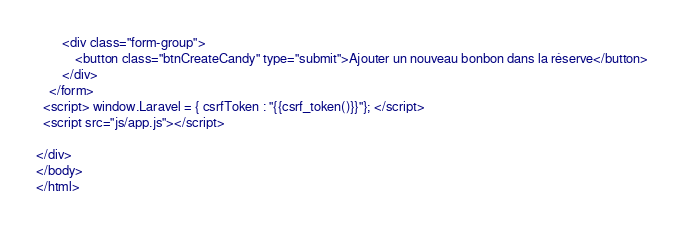Convert code to text. <code><loc_0><loc_0><loc_500><loc_500><_PHP_>        <div class="form-group">
            <button class="btnCreateCandy" type="submit">Ajouter un nouveau bonbon dans la réserve</button>
        </div>
    </form>
  <script> window.Laravel = { csrfToken : "{{csrf_token()}}"}; </script>
  <script src="js/app.js"></script>

</div>
</body>
</html></code> 